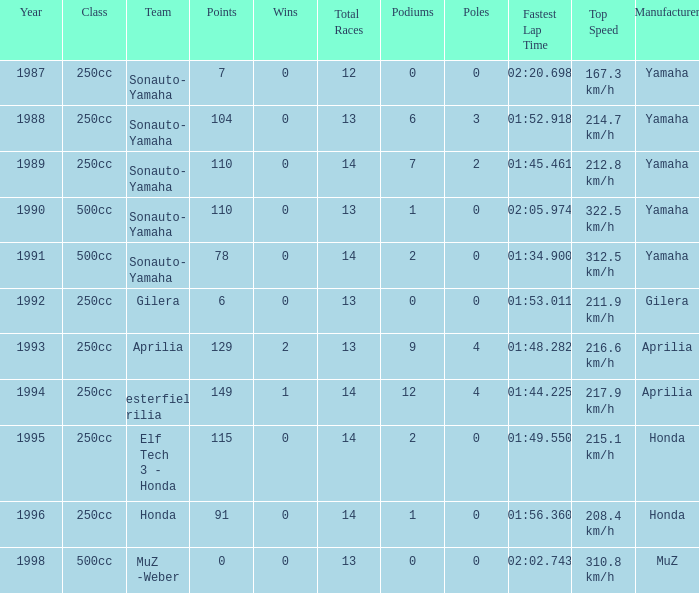How many wins did the team, which had more than 110 points, have in 1989? None. 